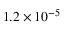<formula> <loc_0><loc_0><loc_500><loc_500>1 . 2 \times 1 0 ^ { - 5 }</formula> 